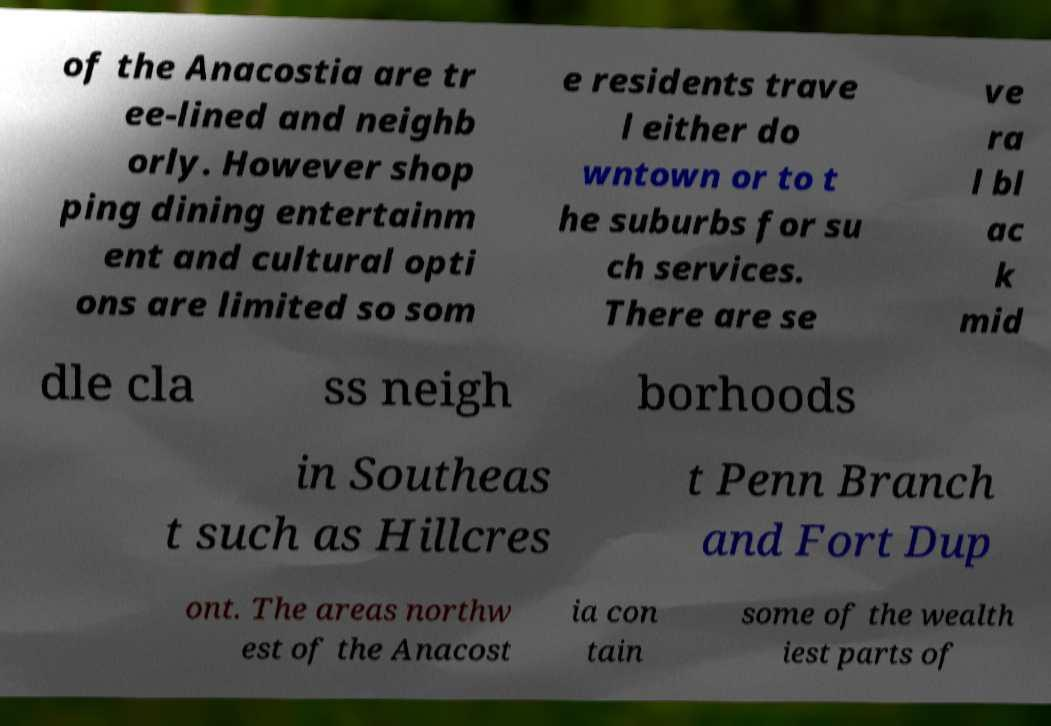Please read and relay the text visible in this image. What does it say? of the Anacostia are tr ee-lined and neighb orly. However shop ping dining entertainm ent and cultural opti ons are limited so som e residents trave l either do wntown or to t he suburbs for su ch services. There are se ve ra l bl ac k mid dle cla ss neigh borhoods in Southeas t such as Hillcres t Penn Branch and Fort Dup ont. The areas northw est of the Anacost ia con tain some of the wealth iest parts of 